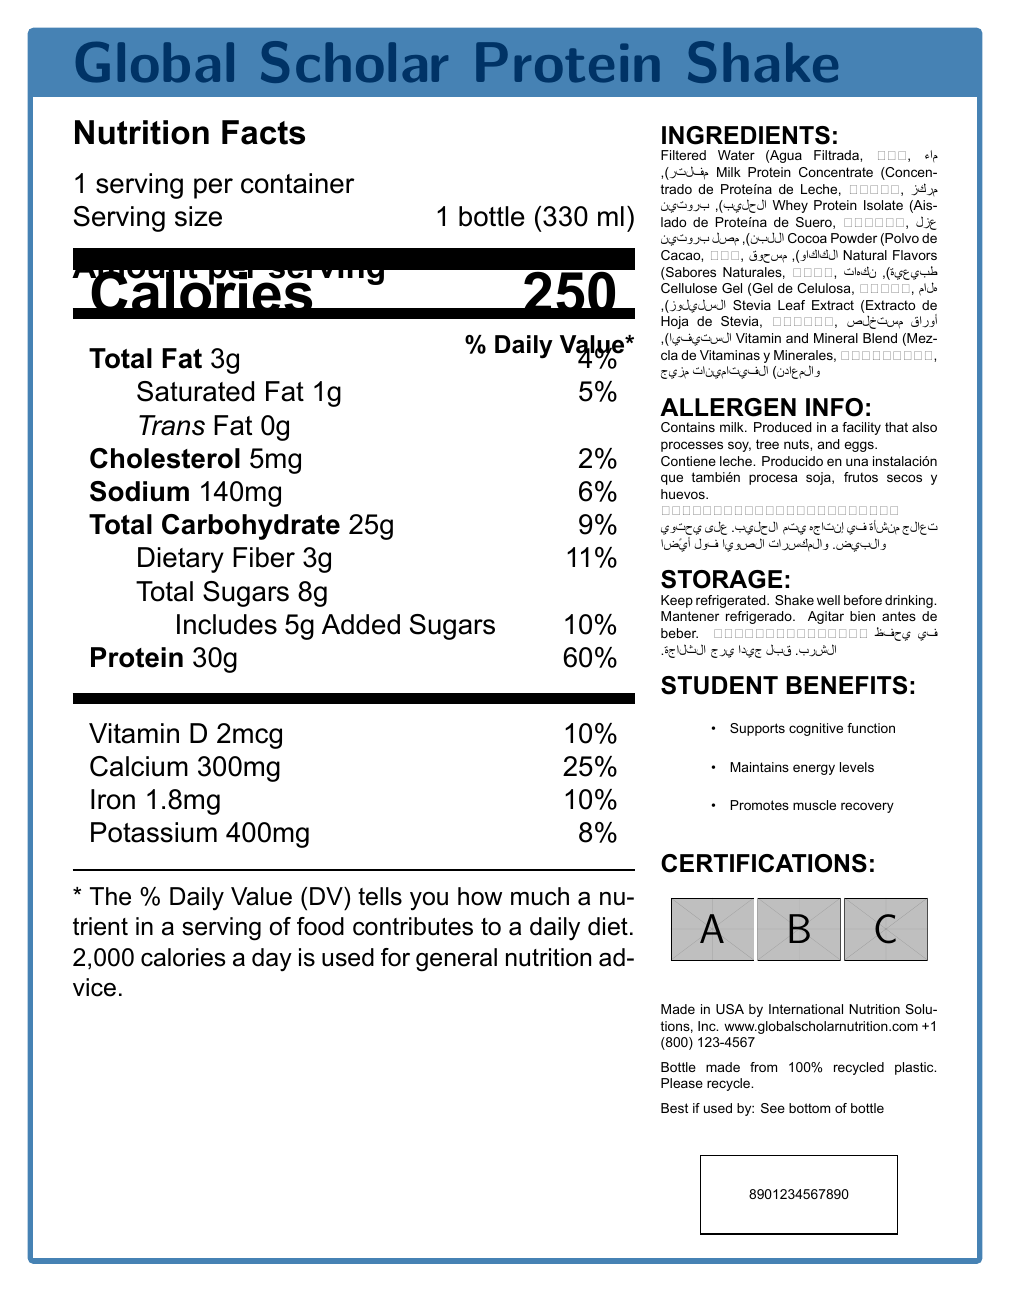what is the serving size of the Global Scholar Protein Shake? The serving size is clearly mentioned on the label as 1 bottle (330 ml).
Answer: 1 bottle (330 ml) how many calories are in one serving of this protein shake? The label states that one serving contains 250 calories.
Answer: 250 calories what is the daily value percentage of protein in this shake? The document lists the daily value percentage of protein as 60%.
Answer: 60% what are the three main benefits that this protein shake provides to students? The document includes a section on student benefits, listing these three main benefits.
Answer: Supports cognitive function, Maintains energy levels, Promotes muscle recovery what languages are used for the ingredient descriptions? The label includes ingredient descriptions in English, Spanish (es), Chinese (zh), and Arabic (ar).
Answer: English, Spanish, Chinese, Arabic how much total fat does one serving of this shake contain? The label lists the total fat content as 3g.
Answer: 3g what ingredients are used to flavor the protein shake naturally? A. Cocoa Powder B. Natural Flavors C. Cellulose Gel D. Stevia Leaf Extract The ingredient labeled "Natural Flavors" is used for natural flavoring.
Answer: B which of the following certifications does the protein shake have? I. Non-GMO Project Verified II. USDA Organic III. Kosher IV. Halal The document states that the shake is Non-GMO Project Verified, Kosher, and Halal certified, but it does not mention USDA Organic.
Answer: I, III, IV does this protein shake contain any allergens? The allergen information states that it contains milk and is produced in a facility that also processes soy, tree nuts, and eggs.
Answer: Yes describe the main idea of the Global Scholar Protein Shake label. This summary gives an overall picture of what is included in the nutrition label, its benefits, composition, and additional important information.
Answer: The Global Scholar Protein Shake provides nutritional information for a protein shake designed for international students. The label includes details on calories, macronutrients, vitamins, and minerals, as well as ingredient descriptions in multiple languages. It highlights benefits for students, such as cognitive support, energy maintenance, and muscle recovery, and includes allergen and storage information, certifications, and sustainability information. who is the manufacturer of this protein shake? The manufacturer is mentioned at the bottom of the document as International Nutrition Solutions, Inc.
Answer: International Nutrition Solutions, Inc. what is the product name? The product name is clearly stated at the beginning of the document as Global Scholar Protein Shake.
Answer: Global Scholar Protein Shake is there any information about cholesterol content provided on the label? The label states the cholesterol content as 5mg (2% Daily Value).
Answer: Yes what is the country of origin for this protein shake? The document mentions that the product is made in the USA.
Answer: Made in USA can we determine the exact expiration date of the protein shake from the document? The document states "Best if used by: See bottom of bottle," so the exact expiration date is not provided within the document itself.
Answer: No what should you do before drinking the shake? The storage instructions clearly say to shake well before drinking.
Answer: Shake well before drinking 